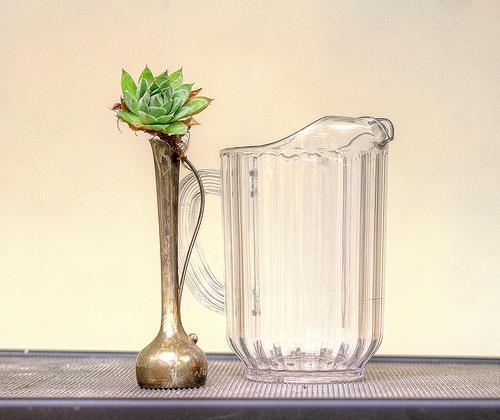How many pictures are in the picture?
Give a very brief answer. 1. 